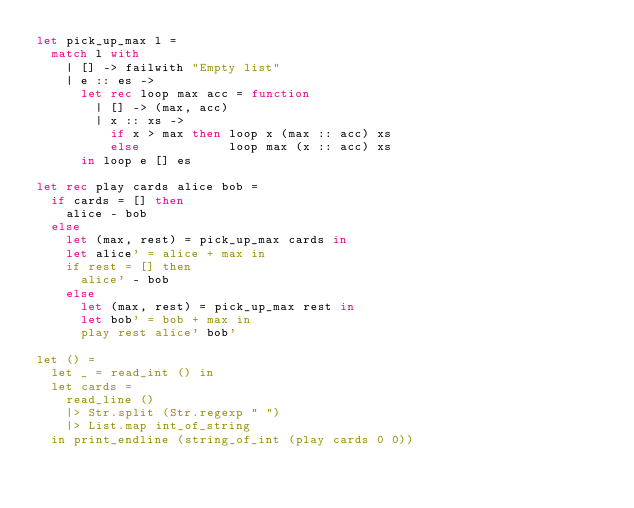Convert code to text. <code><loc_0><loc_0><loc_500><loc_500><_OCaml_>let pick_up_max l =
	match l with
		| [] -> failwith "Empty list"
		| e :: es ->
			let rec loop max acc = function
				| [] -> (max, acc)
				| x :: xs ->
					if x > max then loop x (max :: acc) xs
					else            loop max (x :: acc) xs
			in loop e [] es

let rec play cards alice bob =
	if cards = [] then
		alice - bob
	else
		let (max, rest) = pick_up_max cards in
		let alice' = alice + max in
		if rest = [] then
			alice' - bob
		else
			let (max, rest) = pick_up_max rest in
			let bob' = bob + max in
			play rest alice' bob'

let () =
	let _ = read_int () in
	let cards =
		read_line ()
		|> Str.split (Str.regexp " ")
		|> List.map int_of_string
	in print_endline (string_of_int (play cards 0 0))
</code> 